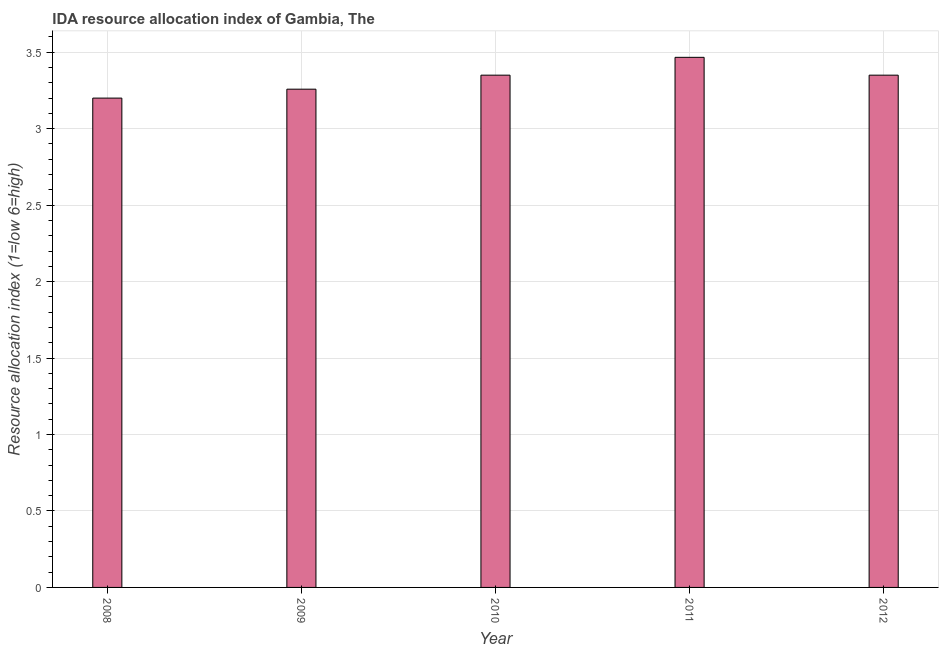Does the graph contain grids?
Your answer should be compact. Yes. What is the title of the graph?
Offer a very short reply. IDA resource allocation index of Gambia, The. What is the label or title of the Y-axis?
Your answer should be compact. Resource allocation index (1=low 6=high). Across all years, what is the maximum ida resource allocation index?
Provide a succinct answer. 3.47. Across all years, what is the minimum ida resource allocation index?
Provide a short and direct response. 3.2. In which year was the ida resource allocation index minimum?
Make the answer very short. 2008. What is the sum of the ida resource allocation index?
Give a very brief answer. 16.62. What is the difference between the ida resource allocation index in 2008 and 2012?
Your answer should be very brief. -0.15. What is the average ida resource allocation index per year?
Offer a very short reply. 3.33. What is the median ida resource allocation index?
Offer a very short reply. 3.35. Is the difference between the ida resource allocation index in 2009 and 2010 greater than the difference between any two years?
Provide a succinct answer. No. What is the difference between the highest and the second highest ida resource allocation index?
Give a very brief answer. 0.12. What is the difference between the highest and the lowest ida resource allocation index?
Offer a terse response. 0.27. In how many years, is the ida resource allocation index greater than the average ida resource allocation index taken over all years?
Give a very brief answer. 3. Are all the bars in the graph horizontal?
Provide a short and direct response. No. Are the values on the major ticks of Y-axis written in scientific E-notation?
Make the answer very short. No. What is the Resource allocation index (1=low 6=high) of 2008?
Provide a short and direct response. 3.2. What is the Resource allocation index (1=low 6=high) of 2009?
Offer a very short reply. 3.26. What is the Resource allocation index (1=low 6=high) in 2010?
Provide a succinct answer. 3.35. What is the Resource allocation index (1=low 6=high) of 2011?
Offer a very short reply. 3.47. What is the Resource allocation index (1=low 6=high) in 2012?
Your answer should be compact. 3.35. What is the difference between the Resource allocation index (1=low 6=high) in 2008 and 2009?
Make the answer very short. -0.06. What is the difference between the Resource allocation index (1=low 6=high) in 2008 and 2011?
Give a very brief answer. -0.27. What is the difference between the Resource allocation index (1=low 6=high) in 2008 and 2012?
Your answer should be compact. -0.15. What is the difference between the Resource allocation index (1=low 6=high) in 2009 and 2010?
Your answer should be very brief. -0.09. What is the difference between the Resource allocation index (1=low 6=high) in 2009 and 2011?
Provide a short and direct response. -0.21. What is the difference between the Resource allocation index (1=low 6=high) in 2009 and 2012?
Ensure brevity in your answer.  -0.09. What is the difference between the Resource allocation index (1=low 6=high) in 2010 and 2011?
Provide a succinct answer. -0.12. What is the difference between the Resource allocation index (1=low 6=high) in 2010 and 2012?
Offer a very short reply. 0. What is the difference between the Resource allocation index (1=low 6=high) in 2011 and 2012?
Your answer should be compact. 0.12. What is the ratio of the Resource allocation index (1=low 6=high) in 2008 to that in 2010?
Provide a short and direct response. 0.95. What is the ratio of the Resource allocation index (1=low 6=high) in 2008 to that in 2011?
Offer a very short reply. 0.92. What is the ratio of the Resource allocation index (1=low 6=high) in 2008 to that in 2012?
Offer a terse response. 0.95. What is the ratio of the Resource allocation index (1=low 6=high) in 2009 to that in 2010?
Your answer should be compact. 0.97. What is the ratio of the Resource allocation index (1=low 6=high) in 2009 to that in 2011?
Your answer should be compact. 0.94. What is the ratio of the Resource allocation index (1=low 6=high) in 2009 to that in 2012?
Offer a very short reply. 0.97. What is the ratio of the Resource allocation index (1=low 6=high) in 2010 to that in 2012?
Your answer should be compact. 1. What is the ratio of the Resource allocation index (1=low 6=high) in 2011 to that in 2012?
Provide a succinct answer. 1.03. 